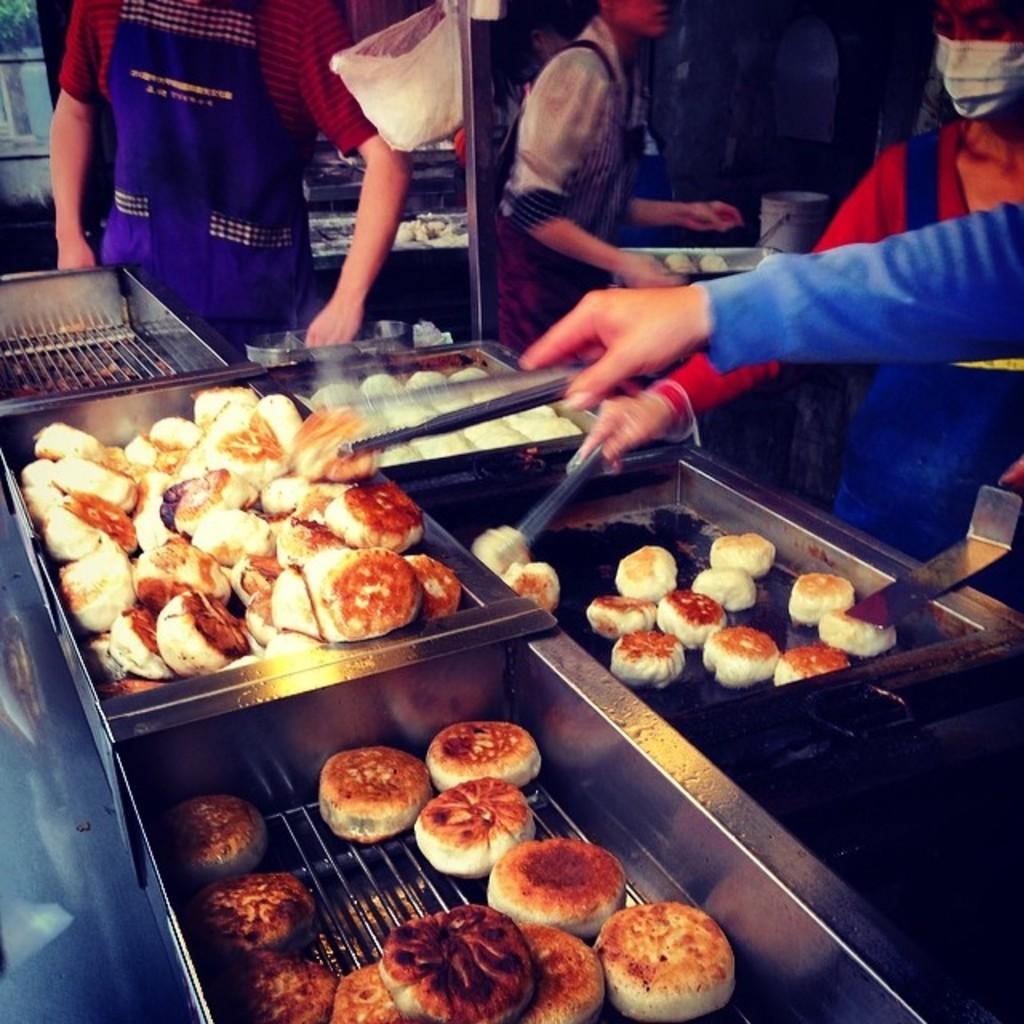Please provide a concise description of this image. This image consists of food which is in the center. On the right side there are persons standing. In the center there is hand of the person holding food. 